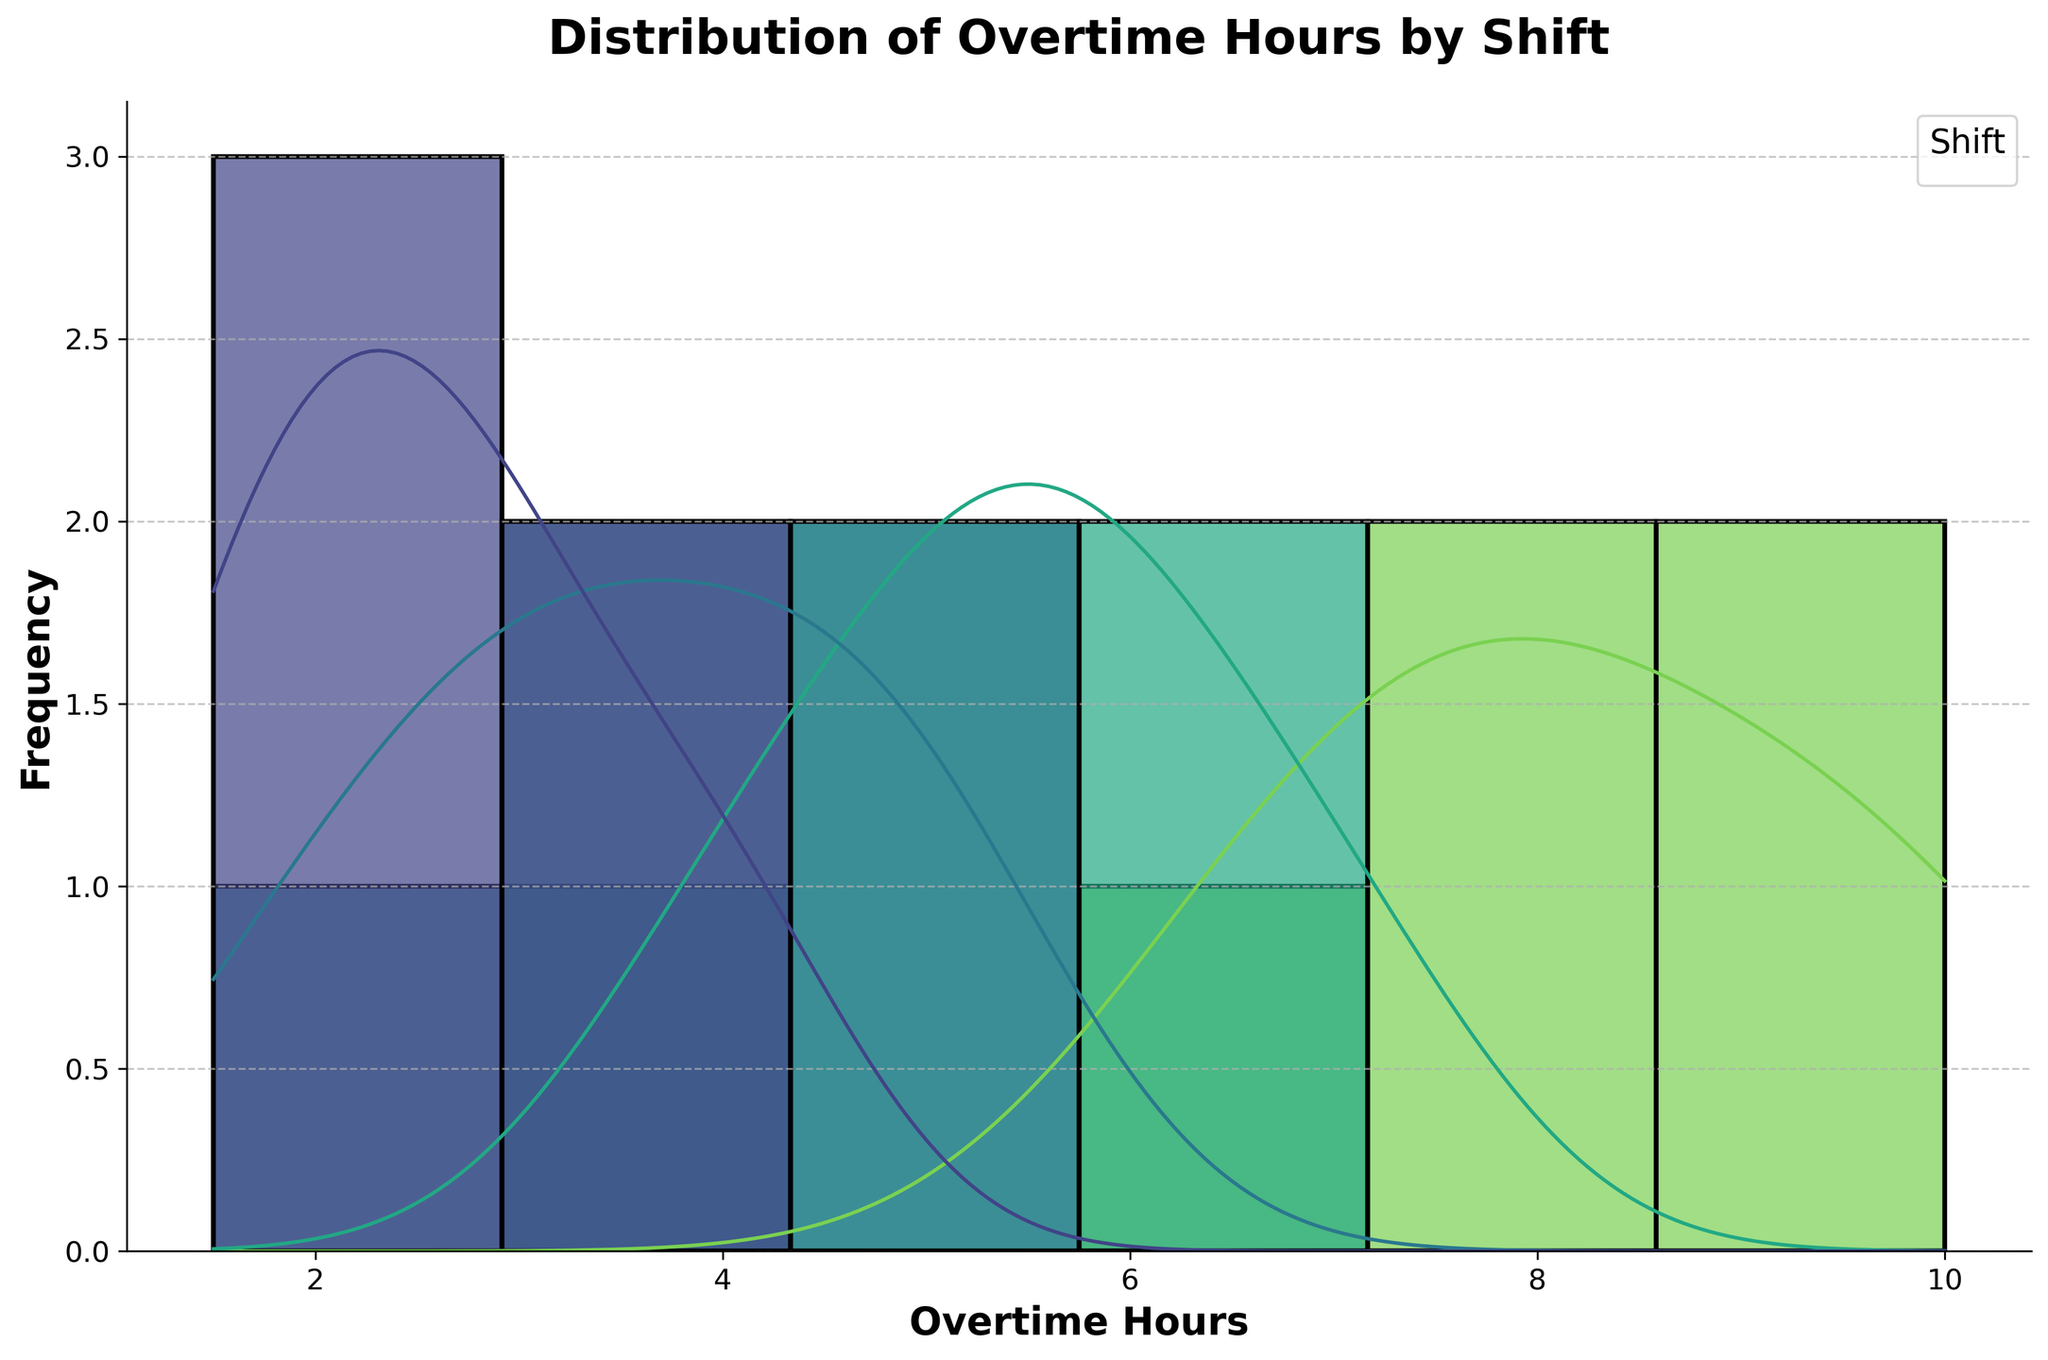What is the title of the plot? The title of the plot is displayed at the top of the figure.
Answer: Distribution of Overtime Hours by Shift What does the x-axis represent? The x-axis represents the measurement for the plot, which is displayed along the horizontal axis.
Answer: Overtime Hours What does the y-axis represent? The y-axis represents the frequency of occurrences, which is displayed along the vertical axis.
Answer: Frequency How many shifts are represented in the plot? The legend on the plot shows the distinct categories of shifts.
Answer: Four shifts Which shift has the highest peak in the density curve? Look at the KDE (density curve) lines for each shift and identify the one with the highest peak.
Answer: Weekend What is the range of overtime hours for the Night shift? Find the starting and ending points of the Night shift data along the x-axis.
Answer: 4 to 7 hours Which shift has workers that do the least amount of overtime on average? Compare the KDE peaks or the general central tendency in each histogram.
Answer: Morning How does the overtime distribution of the Weekend shift compare to the Morning shift? Evaluate the position, spread, and height of the histograms and KDE curves for both Weekend and Morning shifts.
Answer: Weekend shift has higher and more spread out overtime hours than the Morning shift What is the most common overtime range for the Afternoon shift? Identify the interval on the x-axis where the Afternoon shift histogram has the highest bars.
Answer: 3-5 hours Are there any shifts with overlapping overtime hours? Compare the histograms of different shifts to see any overlapping sections.
Answer: Yes, particularly between Afternoon and Night shifts around 4-5 hours 